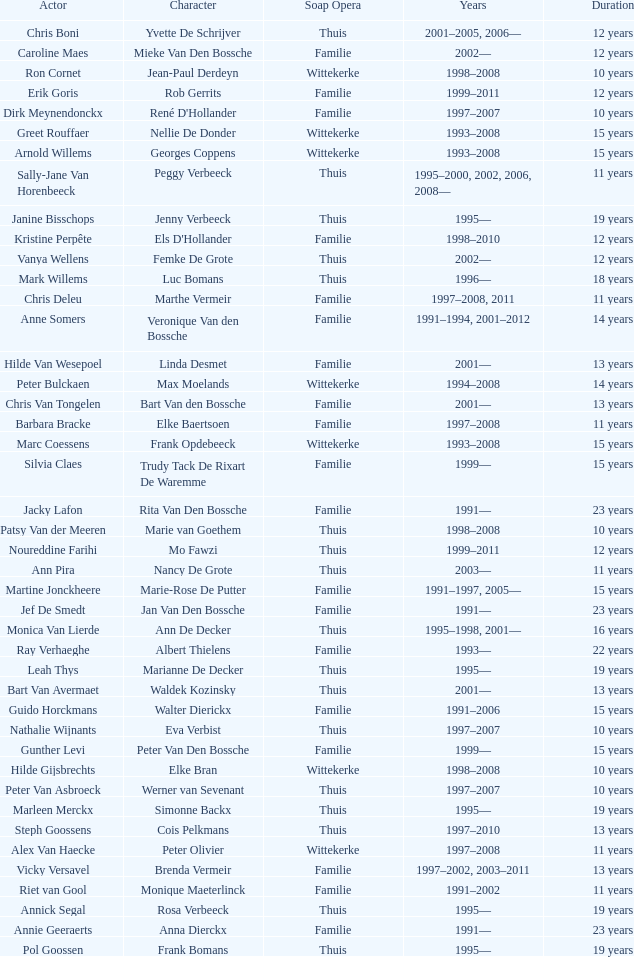What actor plays Marie-Rose De Putter? Martine Jonckheere. 